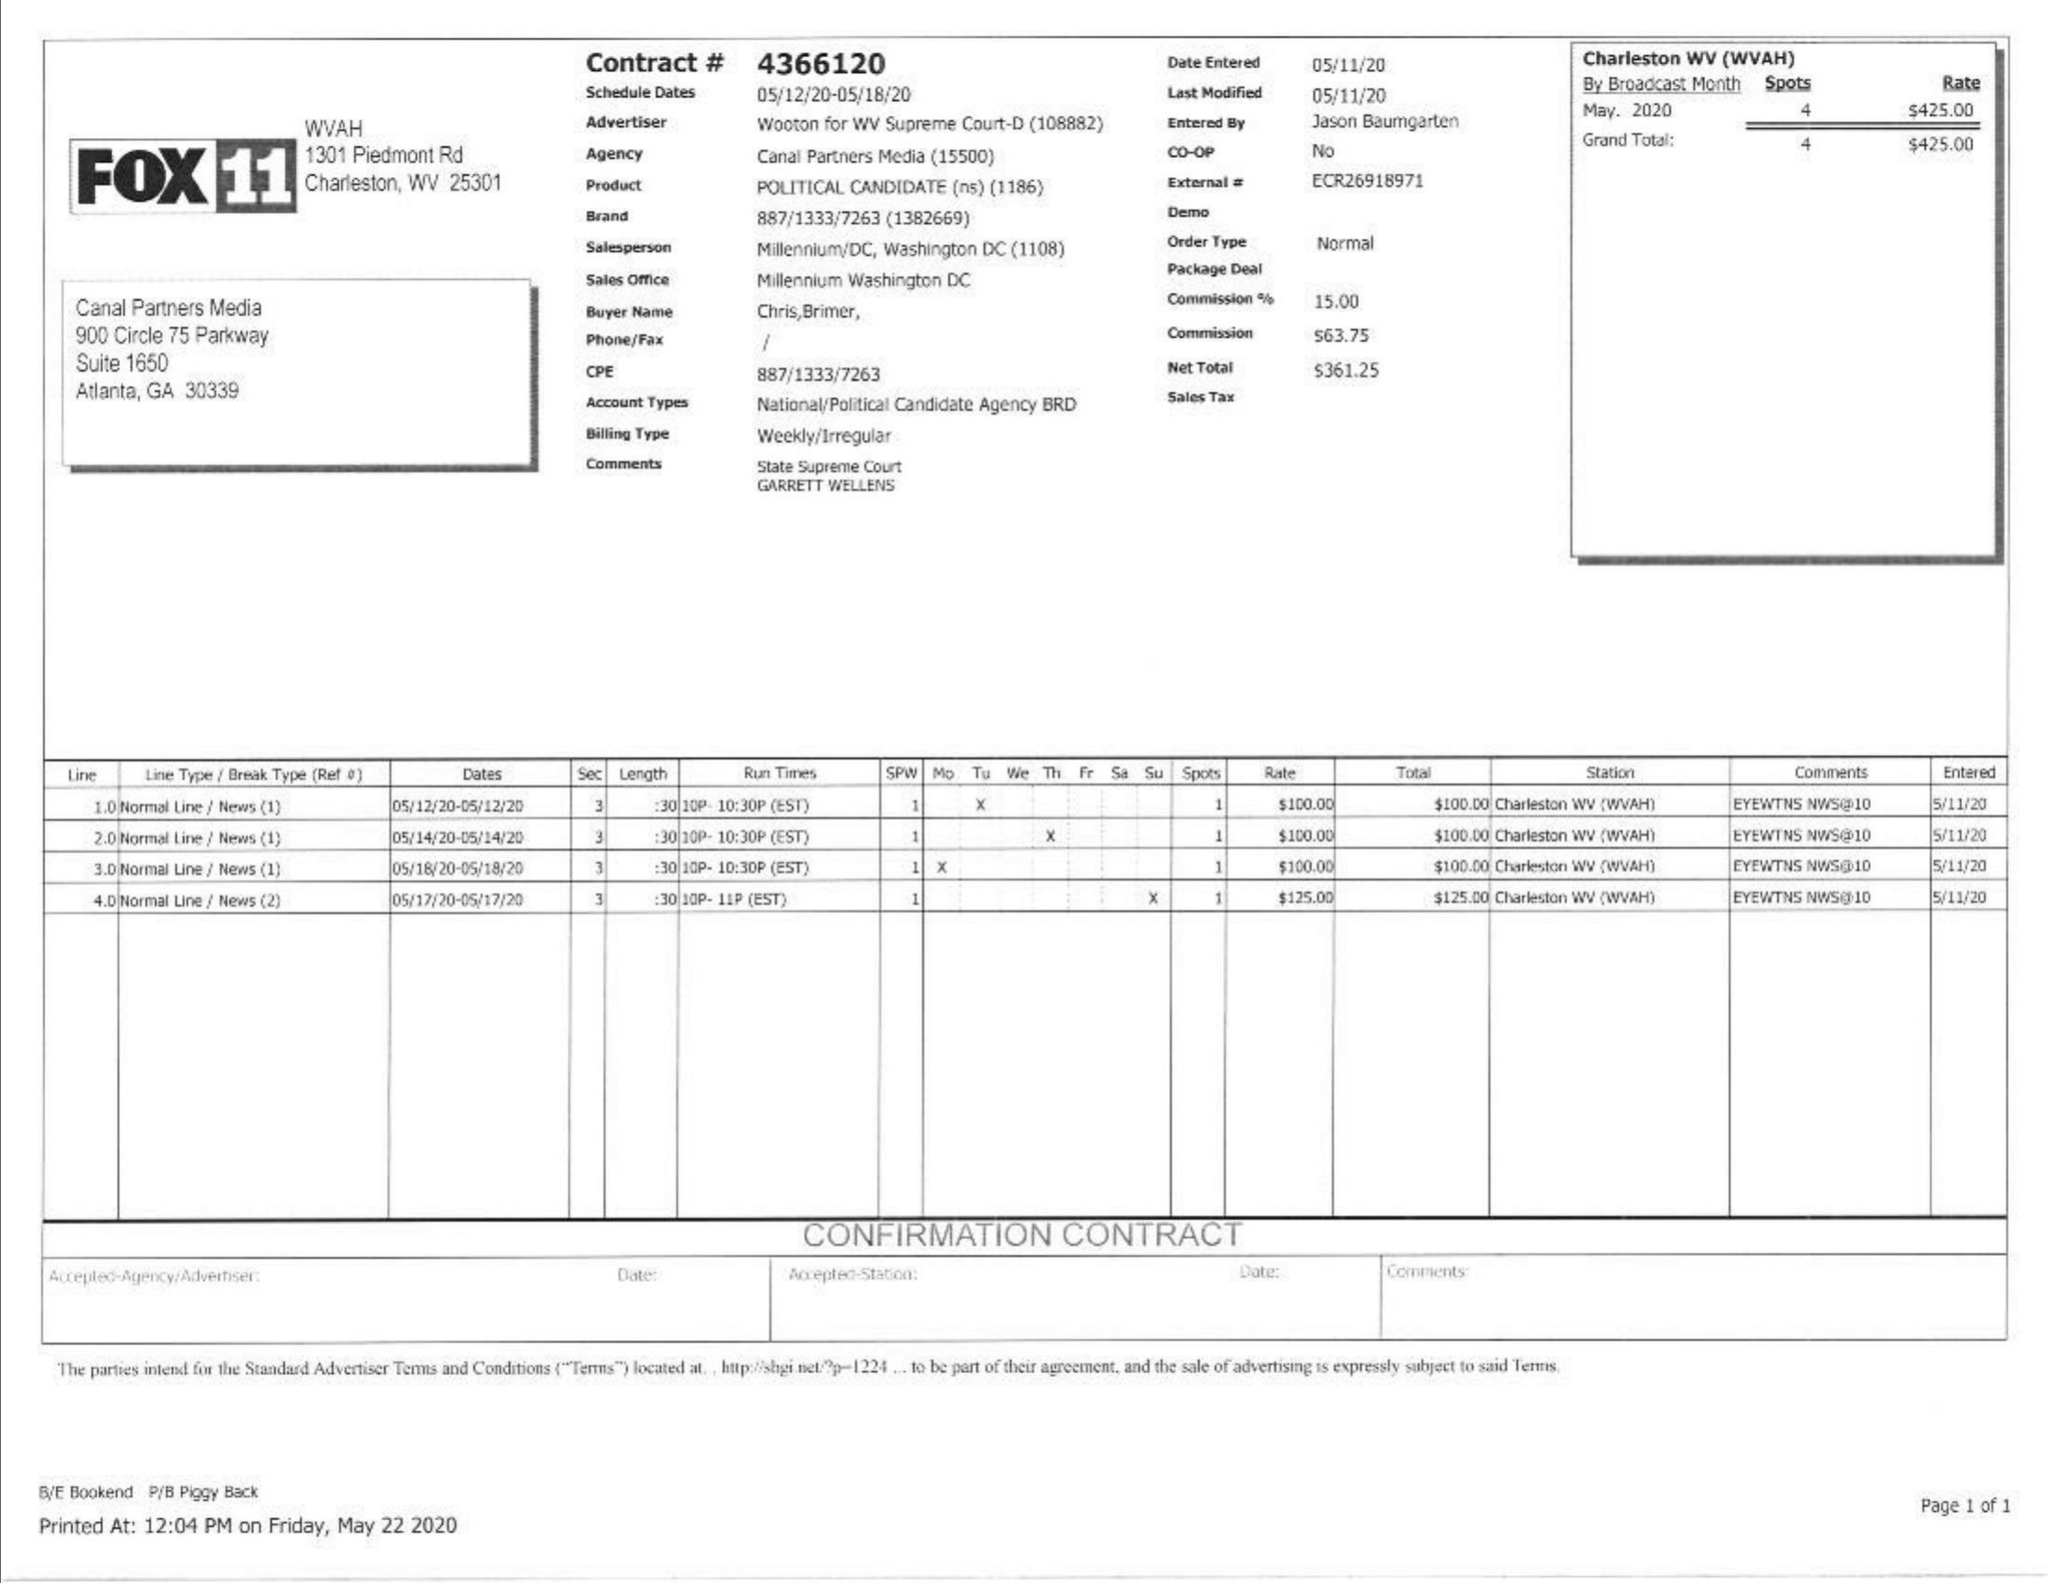What is the value for the flight_to?
Answer the question using a single word or phrase. 05/18/20 